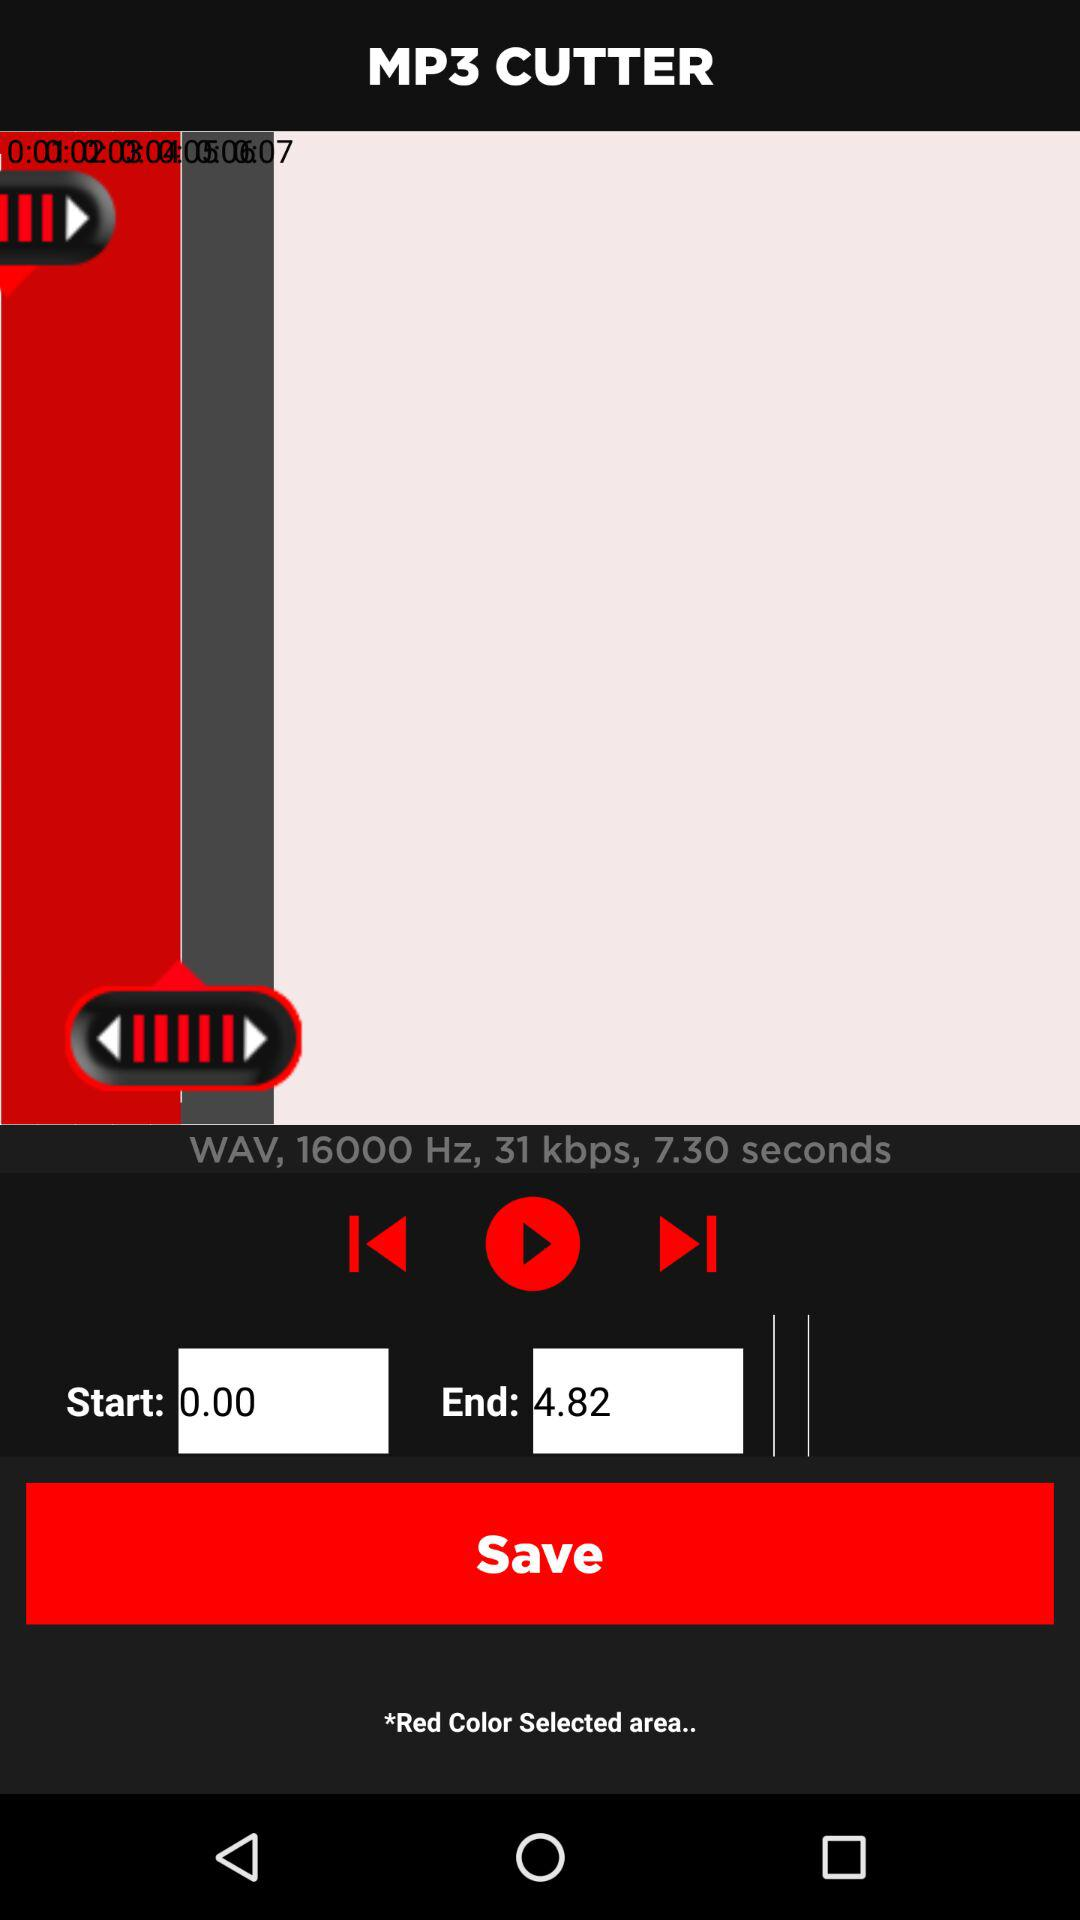How much space is consumed by mp3 cutter?
When the provided information is insufficient, respond with <no answer>. <no answer> 